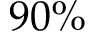Convert formula to latex. <formula><loc_0><loc_0><loc_500><loc_500>9 0 \%</formula> 